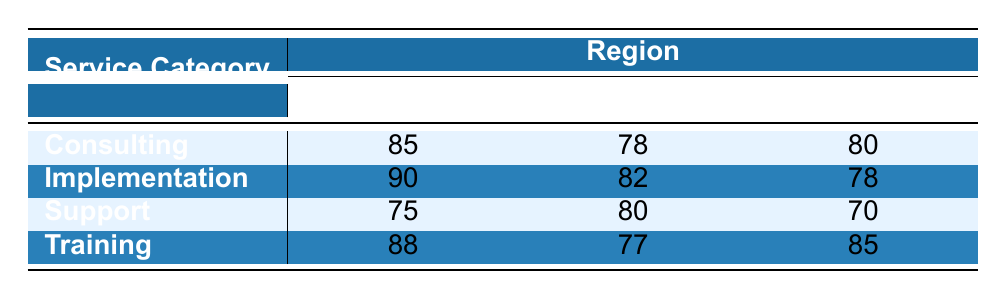What is the satisfaction score for Consulting in North America? The table shows that the satisfaction score for Consulting in North America is listed directly under that row in the respective column, which reads 85.
Answer: 85 What is the highest satisfaction score among the service categories in Europe? Looking at the Europe column, the scores are 78 (Consulting), 82 (Implementation), 80 (Support), and 77 (Training). The highest of these numbers is 82 from the Implementation row.
Answer: 82 Which service category has the lowest satisfaction score in Asia? In the Asia region, the scores are 80 (Consulting), 78 (Implementation), 70 (Support), and 85 (Training). The lowest score is 70 from the Support row.
Answer: Support What is the average satisfaction score for Implementation across all regions? To find the average, first we sum the scores from all regions: 90 (North America) + 82 (Europe) + 78 (Asia) = 250. There are 3 data points, so the average is 250 / 3 = 83.33.
Answer: 83.33 Is the satisfaction score for Training in North America higher than that in Europe? The score for Training in North America is 88, while in Europe it is 77. Since 88 is greater than 77, the answer is yes.
Answer: Yes What is the difference in satisfaction scores between Support in North America and Europe? The score for Support in North America is 75, and in Europe, it is 80. To find the difference, we subtract: 80 - 75 = 5.
Answer: 5 Are there any service categories in Europe with a satisfaction score above 80? Checking the Europe scores (78, 82, 80, 77), only the Implementation score of 82 is above 80. Thus, the answer is yes.
Answer: Yes Which region has the highest satisfaction score for Training? The scores for Training are 88 (North America), 77 (Europe), and 85 (Asia). The highest score is 88 from North America.
Answer: North America What is the total satisfaction score for all services in North America? Summing the scores specifically for North America: 85 (Consulting) + 90 (Implementation) + 75 (Support) + 88 (Training) = 338.
Answer: 338 